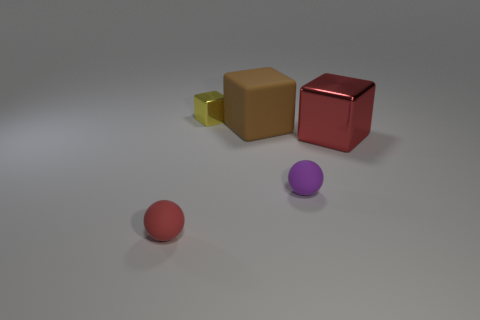Add 4 purple rubber spheres. How many objects exist? 9 Subtract all cubes. How many objects are left? 2 Subtract 1 red balls. How many objects are left? 4 Subtract all gray things. Subtract all tiny red rubber balls. How many objects are left? 4 Add 5 red metal blocks. How many red metal blocks are left? 6 Add 2 small red balls. How many small red balls exist? 3 